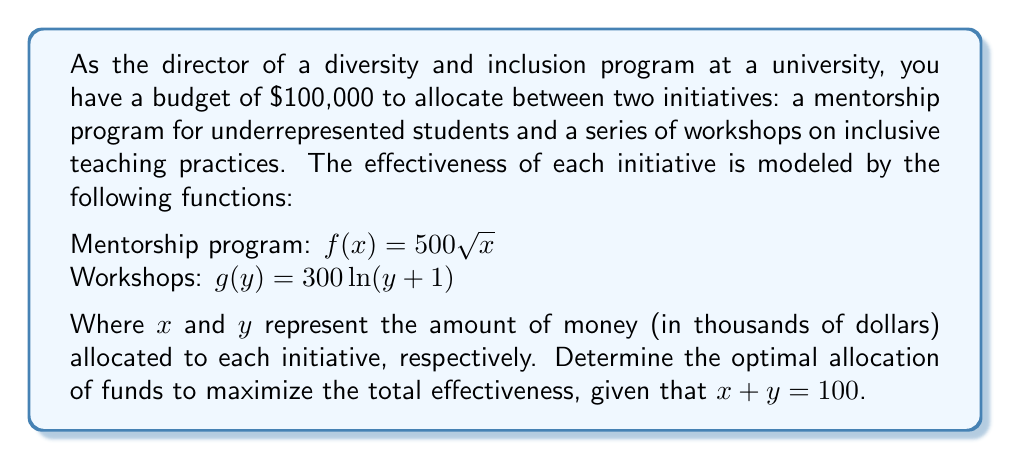Teach me how to tackle this problem. To solve this optimization problem, we'll use the method of Lagrange multipliers:

1) Let $h(x,y) = f(x) + g(y) = 500\sqrt{x} + 300\ln(y+1)$ be the function to maximize.

2) The constraint is $x + y = 100$.

3) Form the Lagrangian function:
   $$L(x,y,\lambda) = 500\sqrt{x} + 300\ln(y+1) - \lambda(x + y - 100)$$

4) Take partial derivatives and set them equal to zero:
   $$\frac{\partial L}{\partial x} = \frac{250}{\sqrt{x}} - \lambda = 0$$
   $$\frac{\partial L}{\partial y} = \frac{300}{y+1} - \lambda = 0$$
   $$\frac{\partial L}{\partial \lambda} = -(x + y - 100) = 0$$

5) From the first two equations:
   $$\frac{250}{\sqrt{x}} = \frac{300}{y+1}$$

6) Simplify:
   $$250(y+1) = 300\sqrt{x}$$
   $$y = \frac{6\sqrt{x}}{5} - 1$$

7) Substitute into the constraint equation:
   $$x + \frac{6\sqrt{x}}{5} - 1 = 100$$
   $$x + \frac{6\sqrt{x}}{5} = 101$$

8) Solve this equation numerically (e.g., using Newton's method) to get:
   $$x \approx 69.44$$

9) Substitute back to find y:
   $$y \approx 30.56$$

Therefore, the optimal allocation is approximately $69,440 to the mentorship program and $30,560 to the workshops.
Answer: Mentorship program: $69,440; Workshops: $30,560 